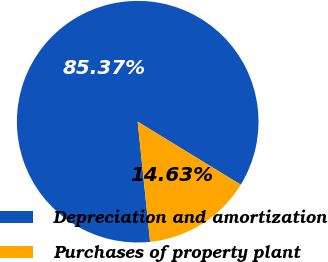Convert chart. <chart><loc_0><loc_0><loc_500><loc_500><pie_chart><fcel>Depreciation and amortization<fcel>Purchases of property plant<nl><fcel>85.37%<fcel>14.63%<nl></chart> 